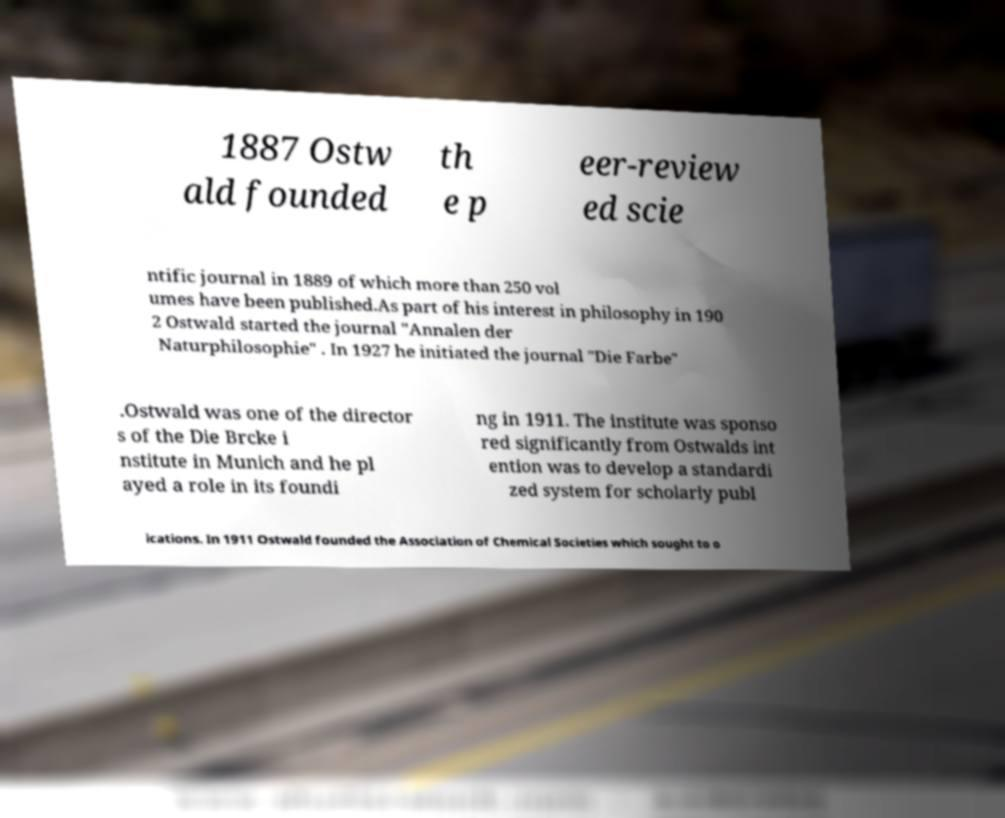Please identify and transcribe the text found in this image. 1887 Ostw ald founded th e p eer-review ed scie ntific journal in 1889 of which more than 250 vol umes have been published.As part of his interest in philosophy in 190 2 Ostwald started the journal "Annalen der Naturphilosophie" . In 1927 he initiated the journal "Die Farbe" .Ostwald was one of the director s of the Die Brcke i nstitute in Munich and he pl ayed a role in its foundi ng in 1911. The institute was sponso red significantly from Ostwalds int ention was to develop a standardi zed system for scholarly publ ications. In 1911 Ostwald founded the Association of Chemical Societies which sought to o 